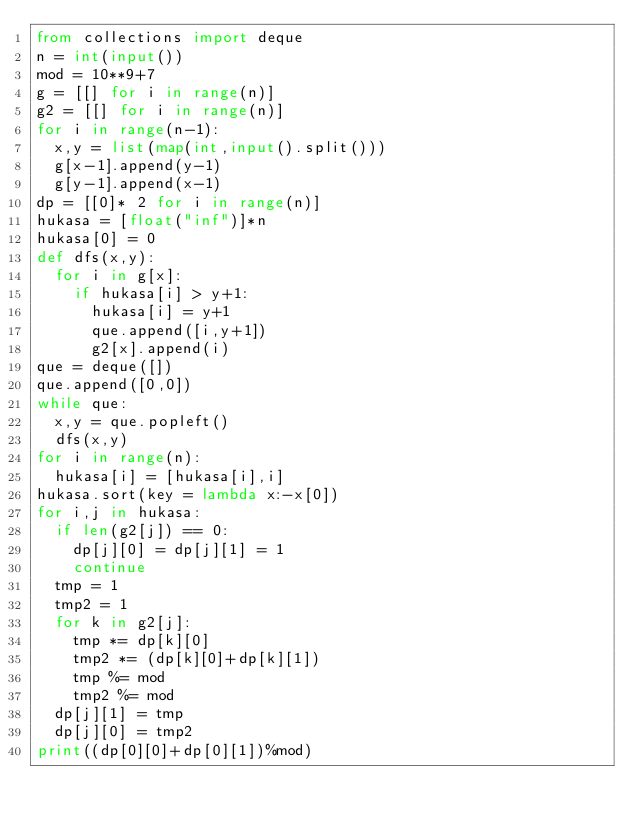<code> <loc_0><loc_0><loc_500><loc_500><_Python_>from collections import deque
n = int(input())
mod = 10**9+7
g = [[] for i in range(n)]
g2 = [[] for i in range(n)]
for i in range(n-1):
  x,y = list(map(int,input().split()))
  g[x-1].append(y-1)
  g[y-1].append(x-1)
dp = [[0]* 2 for i in range(n)]
hukasa = [float("inf")]*n
hukasa[0] = 0
def dfs(x,y):
  for i in g[x]:
    if hukasa[i] > y+1:
      hukasa[i] = y+1
      que.append([i,y+1])
      g2[x].append(i)
que = deque([])
que.append([0,0])
while que:
  x,y = que.popleft()
  dfs(x,y)
for i in range(n):
  hukasa[i] = [hukasa[i],i]
hukasa.sort(key = lambda x:-x[0])
for i,j in hukasa:
  if len(g2[j]) == 0:
    dp[j][0] = dp[j][1] = 1
    continue
  tmp = 1
  tmp2 = 1
  for k in g2[j]:
    tmp *= dp[k][0]
    tmp2 *= (dp[k][0]+dp[k][1])
    tmp %= mod
    tmp2 %= mod
  dp[j][1] = tmp
  dp[j][0] = tmp2
print((dp[0][0]+dp[0][1])%mod)</code> 